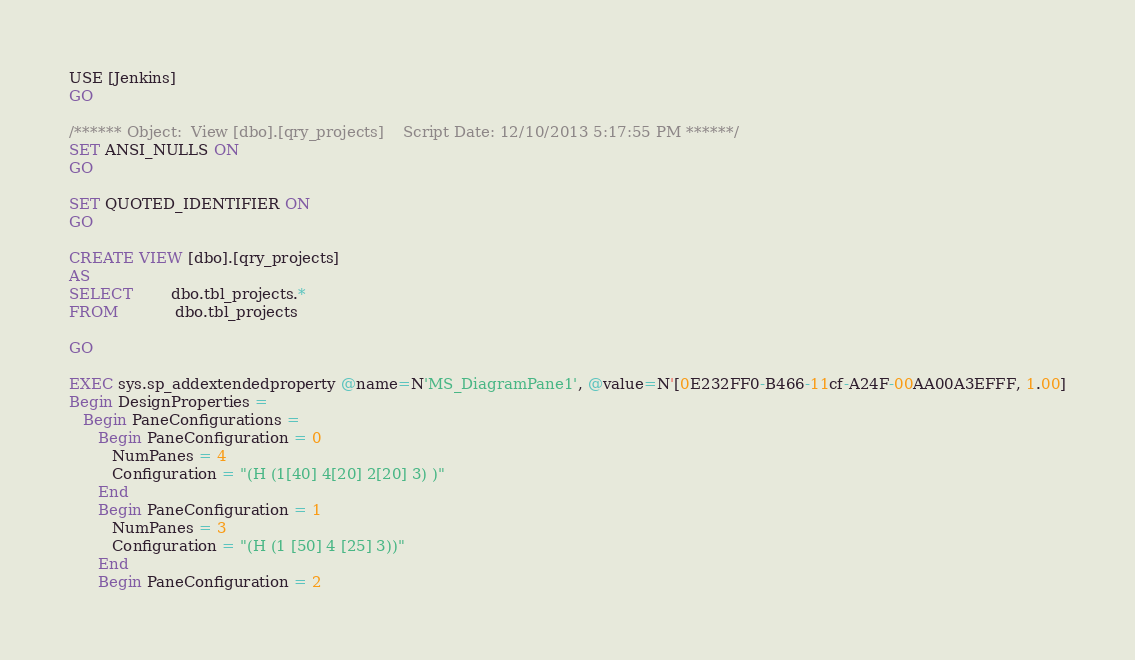<code> <loc_0><loc_0><loc_500><loc_500><_SQL_>USE [Jenkins]
GO

/****** Object:  View [dbo].[qry_projects]    Script Date: 12/10/2013 5:17:55 PM ******/
SET ANSI_NULLS ON
GO

SET QUOTED_IDENTIFIER ON
GO

CREATE VIEW [dbo].[qry_projects]
AS
SELECT        dbo.tbl_projects.*
FROM            dbo.tbl_projects

GO

EXEC sys.sp_addextendedproperty @name=N'MS_DiagramPane1', @value=N'[0E232FF0-B466-11cf-A24F-00AA00A3EFFF, 1.00]
Begin DesignProperties = 
   Begin PaneConfigurations = 
      Begin PaneConfiguration = 0
         NumPanes = 4
         Configuration = "(H (1[40] 4[20] 2[20] 3) )"
      End
      Begin PaneConfiguration = 1
         NumPanes = 3
         Configuration = "(H (1 [50] 4 [25] 3))"
      End
      Begin PaneConfiguration = 2</code> 